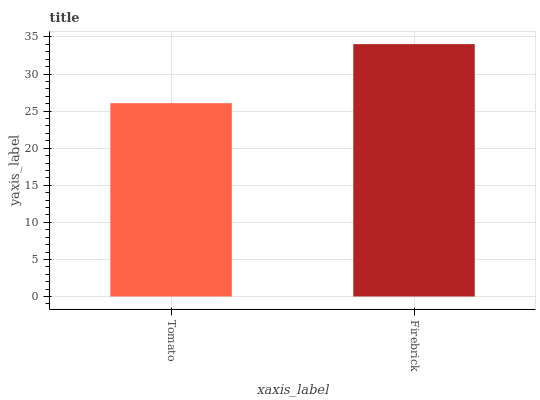Is Firebrick the minimum?
Answer yes or no. No. Is Firebrick greater than Tomato?
Answer yes or no. Yes. Is Tomato less than Firebrick?
Answer yes or no. Yes. Is Tomato greater than Firebrick?
Answer yes or no. No. Is Firebrick less than Tomato?
Answer yes or no. No. Is Firebrick the high median?
Answer yes or no. Yes. Is Tomato the low median?
Answer yes or no. Yes. Is Tomato the high median?
Answer yes or no. No. Is Firebrick the low median?
Answer yes or no. No. 